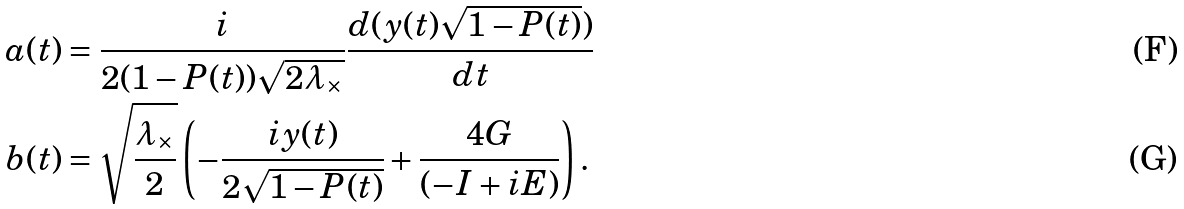<formula> <loc_0><loc_0><loc_500><loc_500>a ( t ) & = \frac { i } { 2 ( 1 - P ( t ) ) \sqrt { 2 \lambda _ { \times } } } \frac { d ( y ( t ) \sqrt { 1 - P ( t ) } ) } { d t } \\ b ( t ) & = \sqrt { \frac { \lambda _ { \times } } { 2 } } \left ( - \frac { i y ( t ) } { 2 \sqrt { 1 - P ( t ) } } + \frac { 4 G } { ( - I + i E ) } \right ) .</formula> 